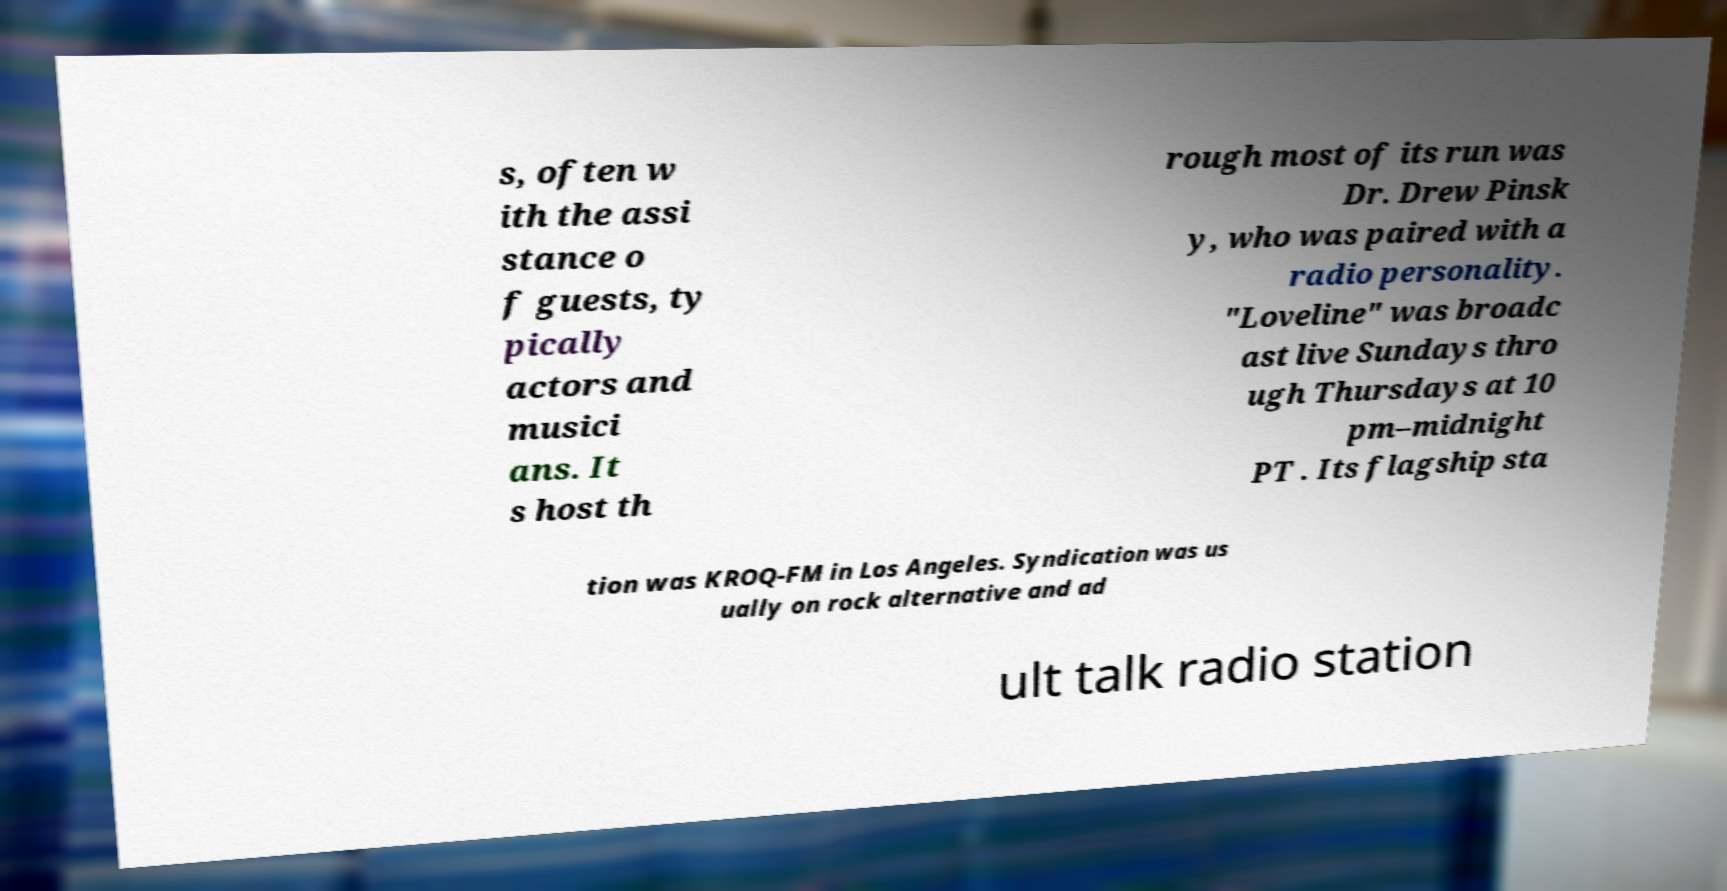There's text embedded in this image that I need extracted. Can you transcribe it verbatim? s, often w ith the assi stance o f guests, ty pically actors and musici ans. It s host th rough most of its run was Dr. Drew Pinsk y, who was paired with a radio personality. "Loveline" was broadc ast live Sundays thro ugh Thursdays at 10 pm–midnight PT . Its flagship sta tion was KROQ-FM in Los Angeles. Syndication was us ually on rock alternative and ad ult talk radio station 